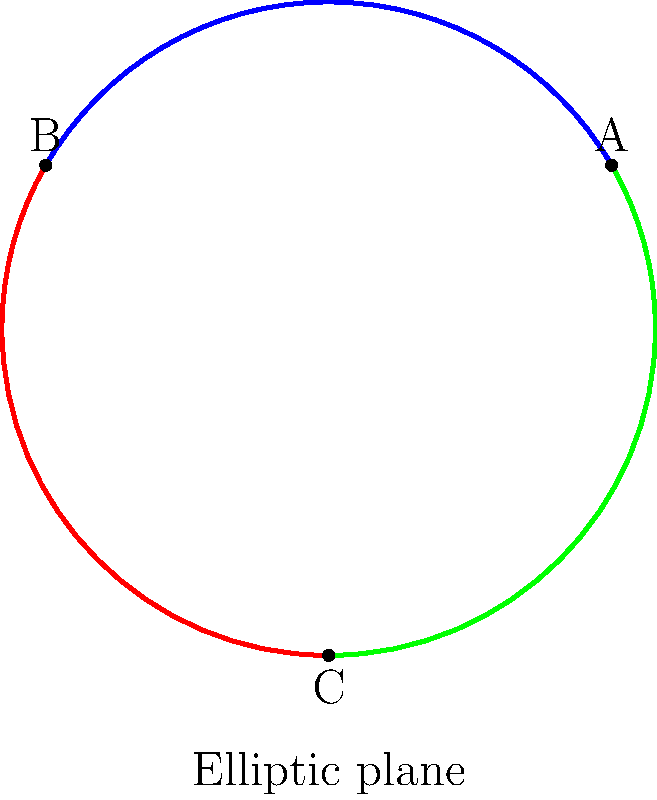In the context of non-Euclidean geometry, specifically elliptic geometry, how do parallel lines behave differently from Euclidean geometry? Explain using the illustration provided, which shows three "lines" on the surface of a sphere. To understand the behavior of parallel lines in elliptic geometry, let's follow these steps:

1. In elliptic geometry, "lines" are represented as great circles on the surface of a sphere. The illustration shows three such lines in different colors.

2. In Euclidean geometry, parallel lines never intersect. However, in elliptic geometry, this is not the case.

3. Observe the blue and red lines in the diagram. They intersect at two points: B and its antipodal point (not shown, but it would be on the opposite side of the sphere).

4. Similarly, the red and green lines intersect at C and its antipode, while the blue and green lines intersect at A and its antipode.

5. This demonstrates that any two "lines" in elliptic geometry always intersect at exactly two points, which are antipodal to each other on the sphere.

6. As a result, the concept of parallel lines as we know it in Euclidean geometry does not exist in elliptic geometry.

7. This property of elliptic geometry challenges our intuitive understanding of space, which is based on Euclidean geometry. It illustrates how spatial relationships can fundamentally change in different geometric systems.

8. From a psychological perspective, this concept may be difficult for individuals to grasp intuitively, as our everyday experiences are based on approximately Euclidean space.
Answer: In elliptic geometry, all lines (great circles) intersect at two antipodal points; parallel lines do not exist. 